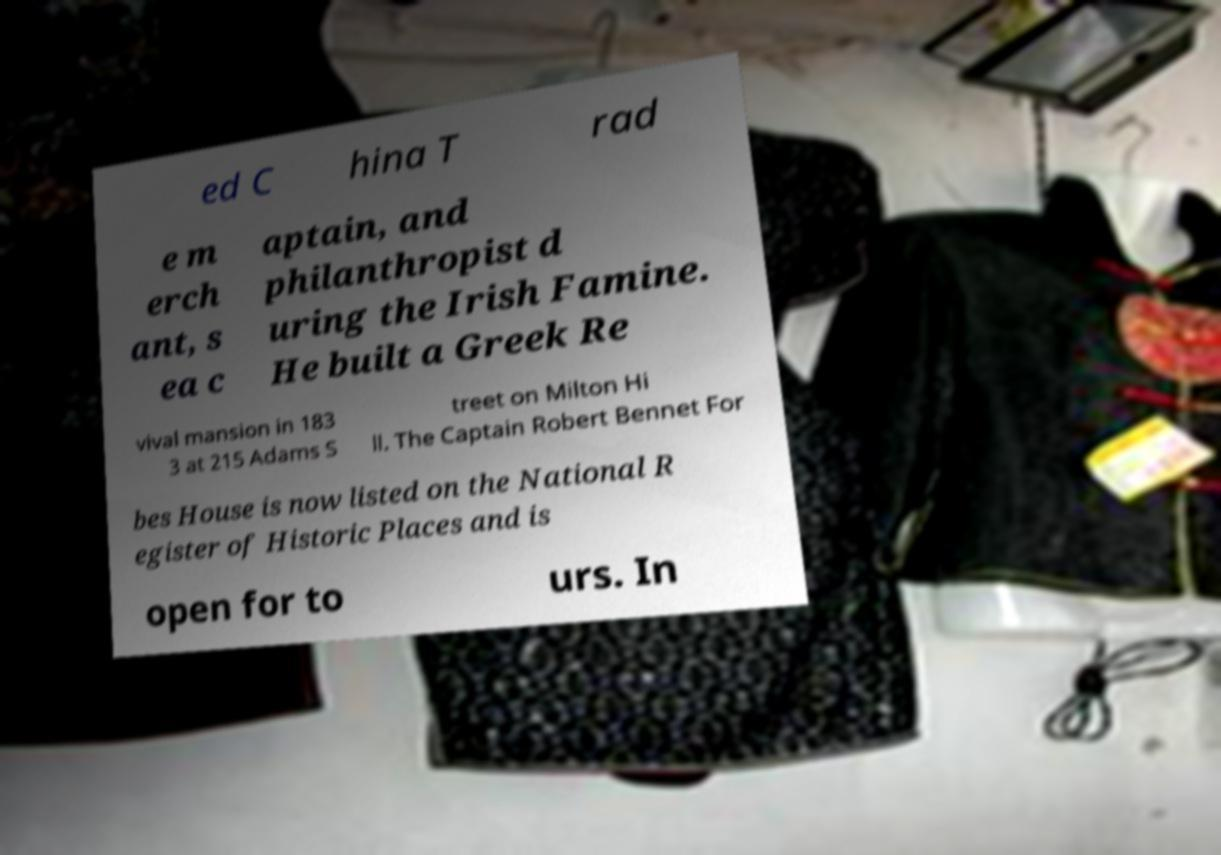There's text embedded in this image that I need extracted. Can you transcribe it verbatim? ed C hina T rad e m erch ant, s ea c aptain, and philanthropist d uring the Irish Famine. He built a Greek Re vival mansion in 183 3 at 215 Adams S treet on Milton Hi ll. The Captain Robert Bennet For bes House is now listed on the National R egister of Historic Places and is open for to urs. In 